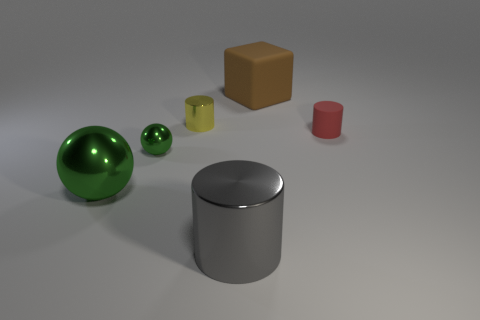There is a big thing that is left of the yellow cylinder; is it the same shape as the yellow thing?
Make the answer very short. No. How many purple objects are either large cubes or matte cylinders?
Your answer should be compact. 0. Are there an equal number of large brown matte cubes that are in front of the large matte cube and green shiny balls that are in front of the gray thing?
Provide a short and direct response. Yes. What color is the matte object in front of the big object that is on the right side of the metallic cylinder on the right side of the tiny yellow cylinder?
Provide a short and direct response. Red. Are there any other things that have the same color as the large cylinder?
Give a very brief answer. No. The big metal thing that is the same color as the small ball is what shape?
Offer a terse response. Sphere. There is a green object that is in front of the small green shiny object; what size is it?
Provide a succinct answer. Large. There is a green object that is the same size as the yellow thing; what is its shape?
Provide a short and direct response. Sphere. Are the big thing on the left side of the yellow thing and the cylinder right of the big rubber object made of the same material?
Ensure brevity in your answer.  No. What is the large thing that is behind the small object that is on the right side of the large gray thing made of?
Provide a short and direct response. Rubber. 